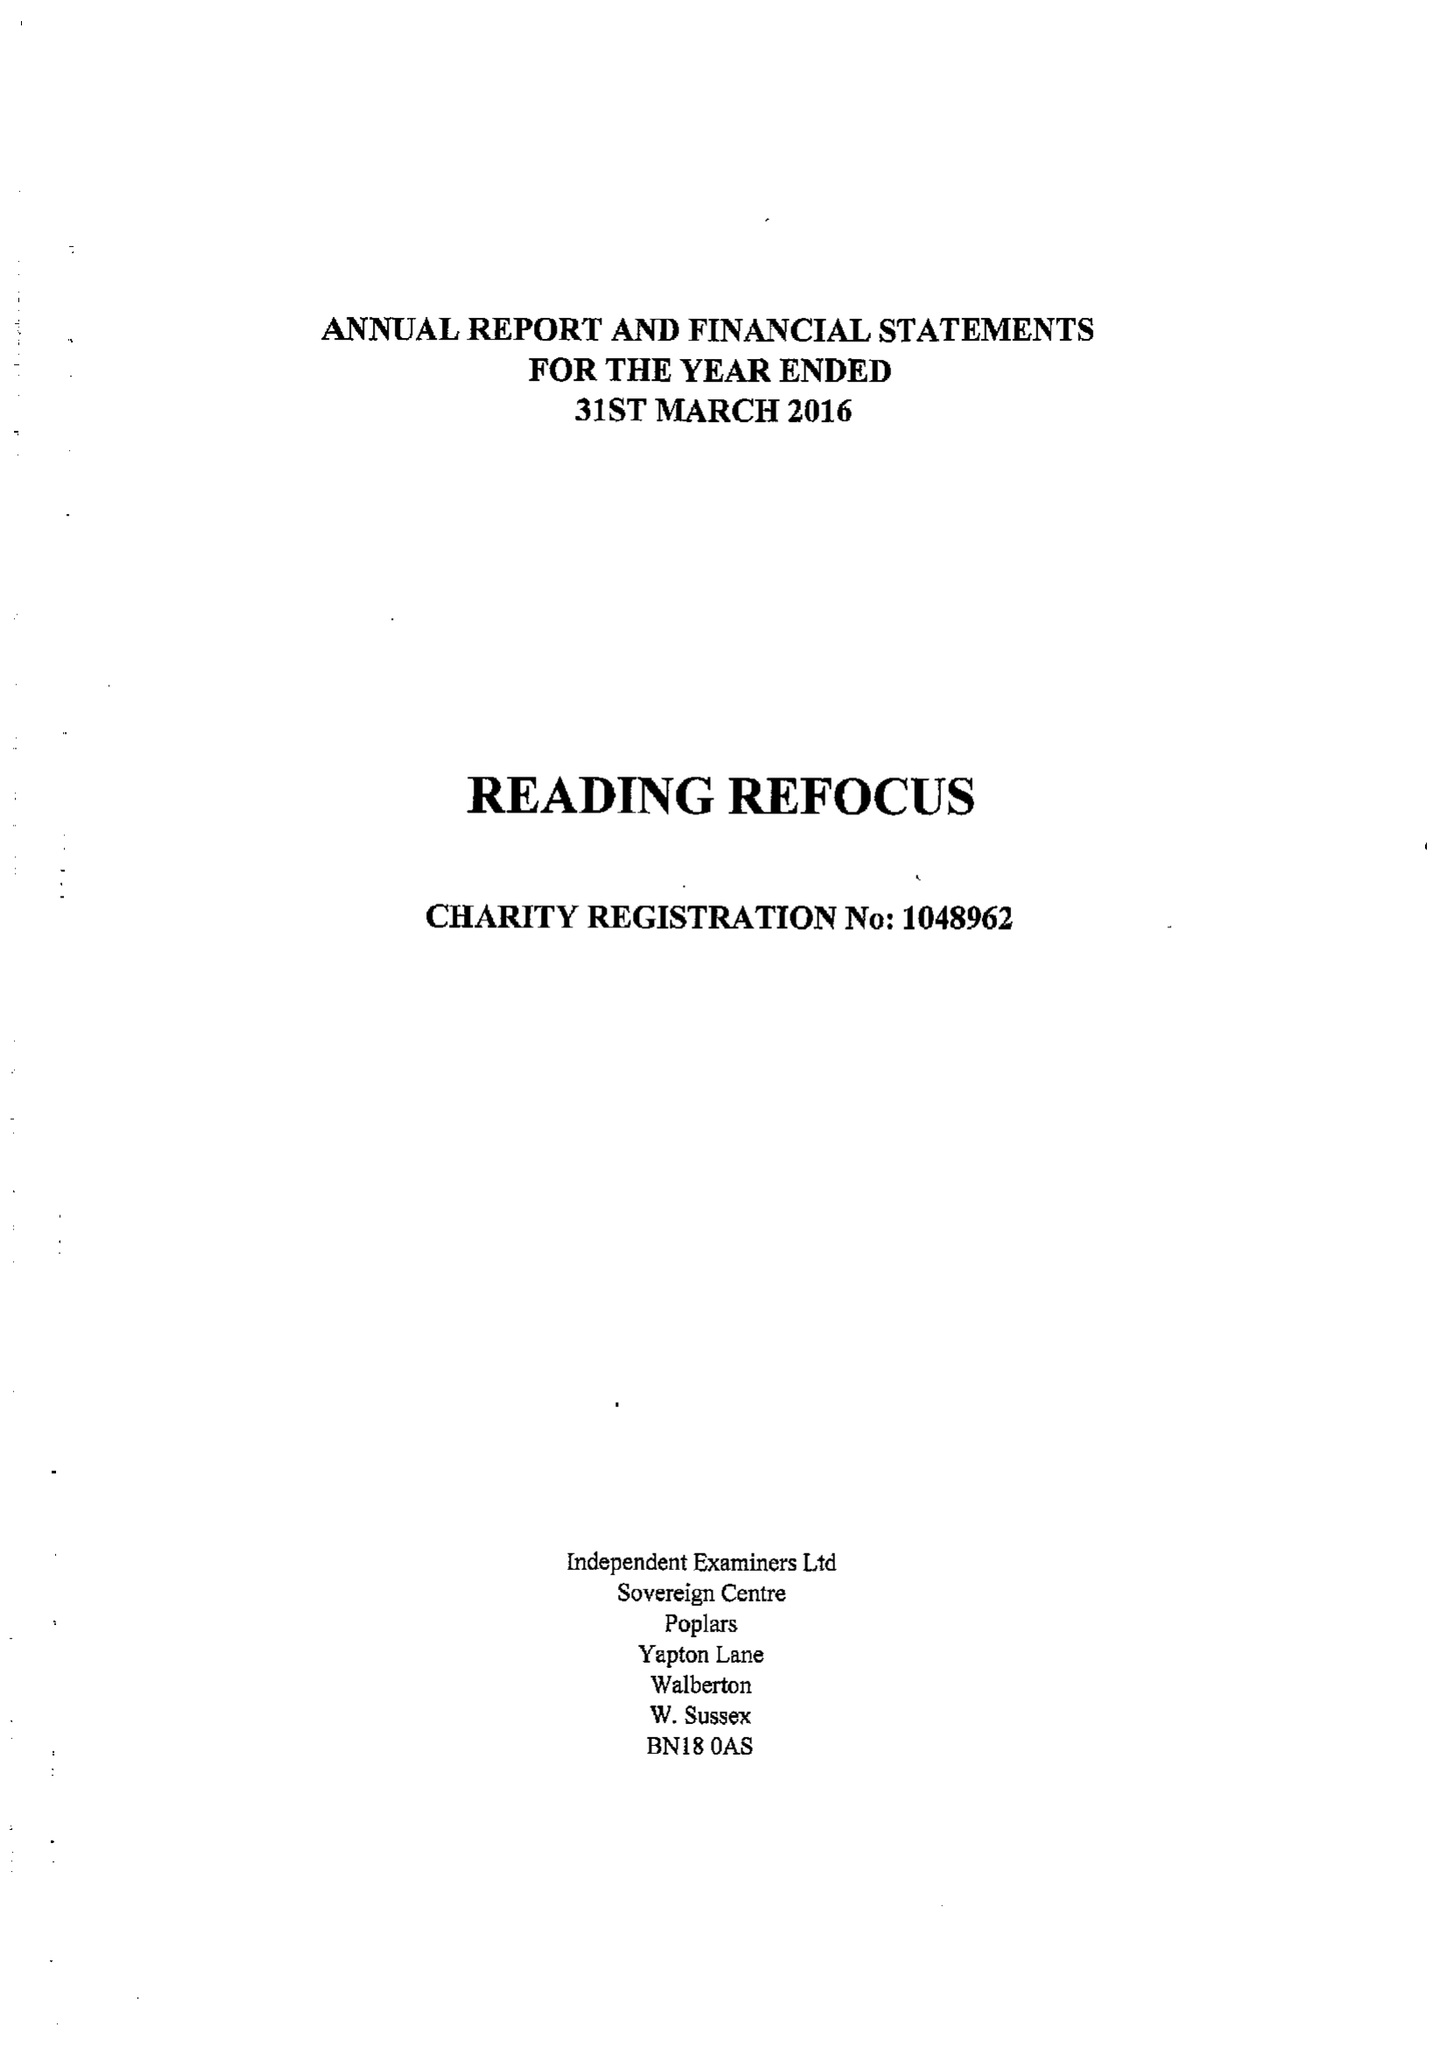What is the value for the address__postcode?
Answer the question using a single word or phrase. RG1 4QU 